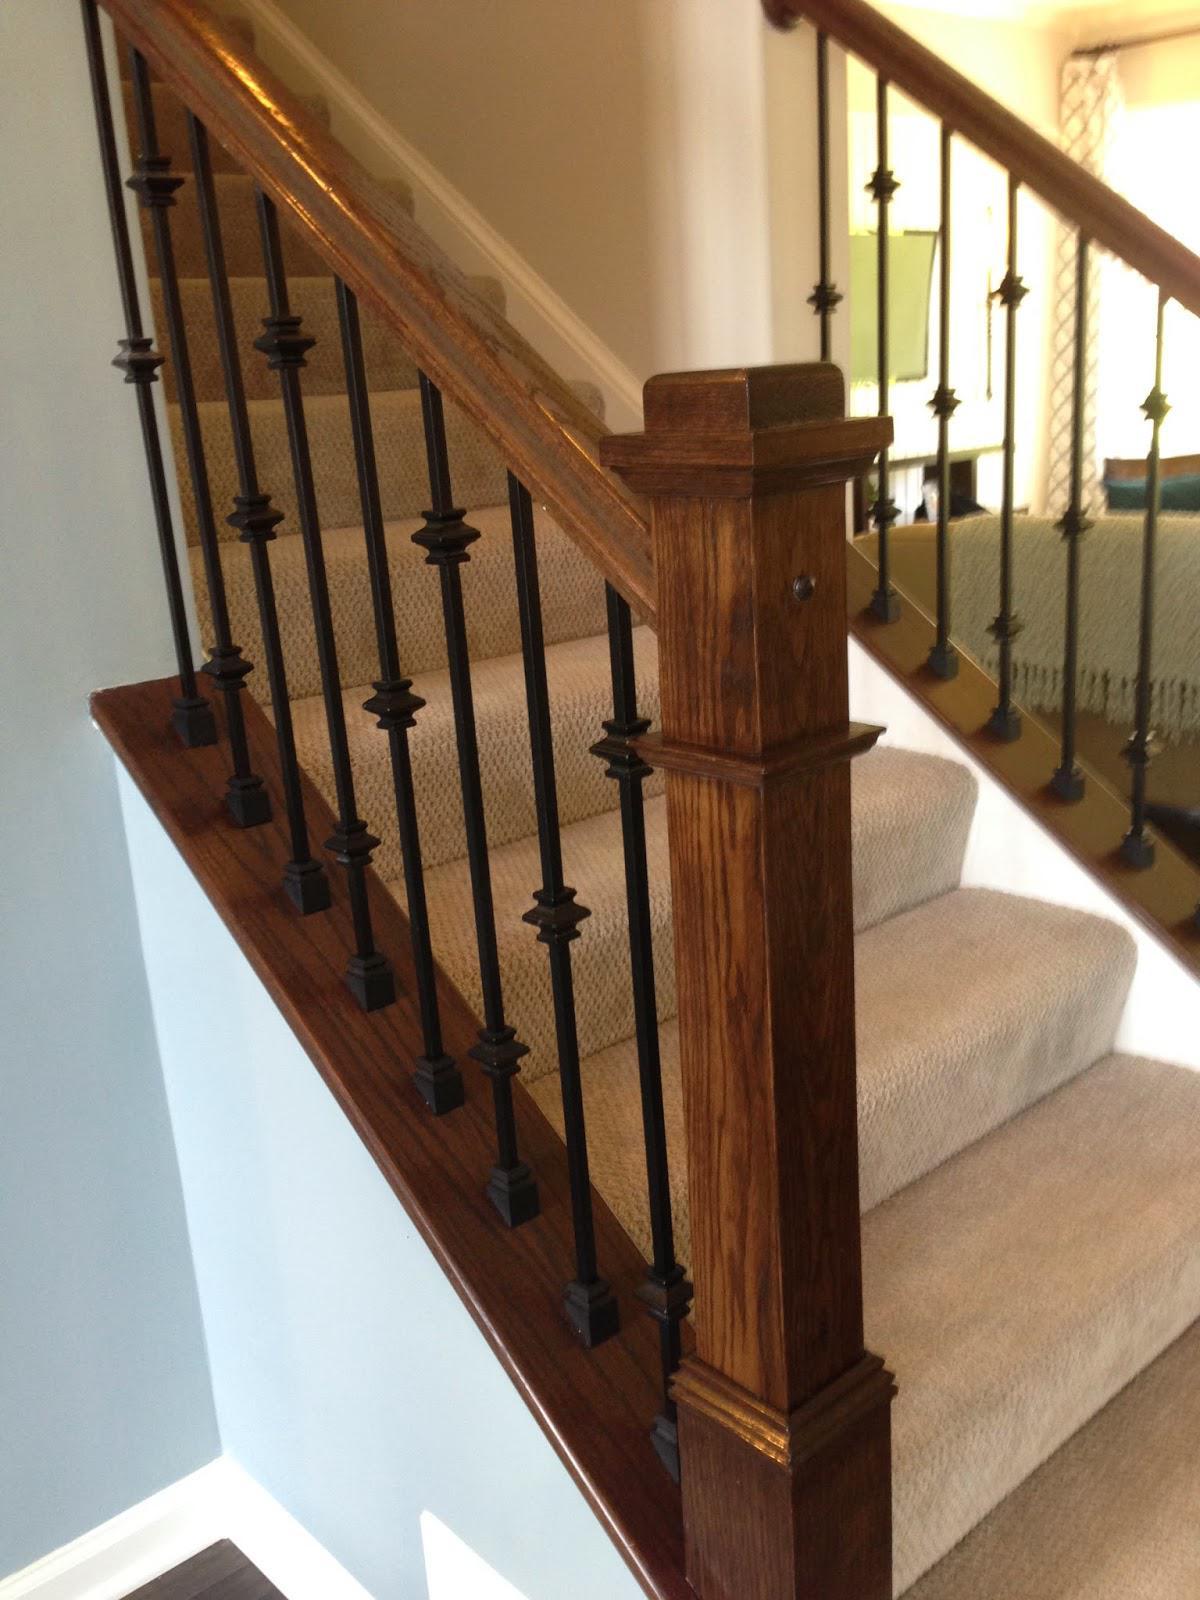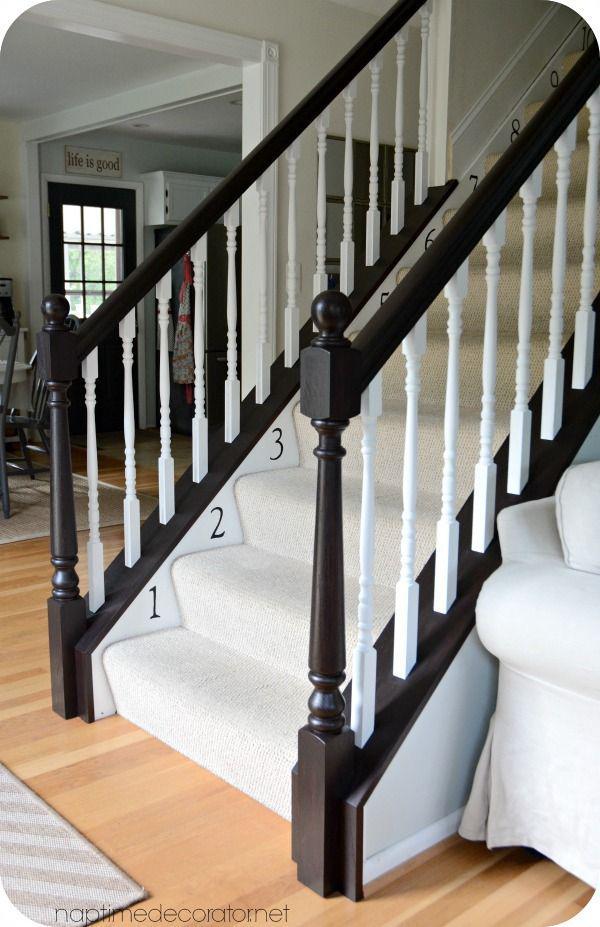The first image is the image on the left, the second image is the image on the right. Given the left and right images, does the statement "All the vertical stairway railings are black." hold true? Answer yes or no. No. The first image is the image on the left, the second image is the image on the right. Analyze the images presented: Is the assertion "One image in the pair shows carpeted stairs and the other shows uncarpeted stairs." valid? Answer yes or no. No. 